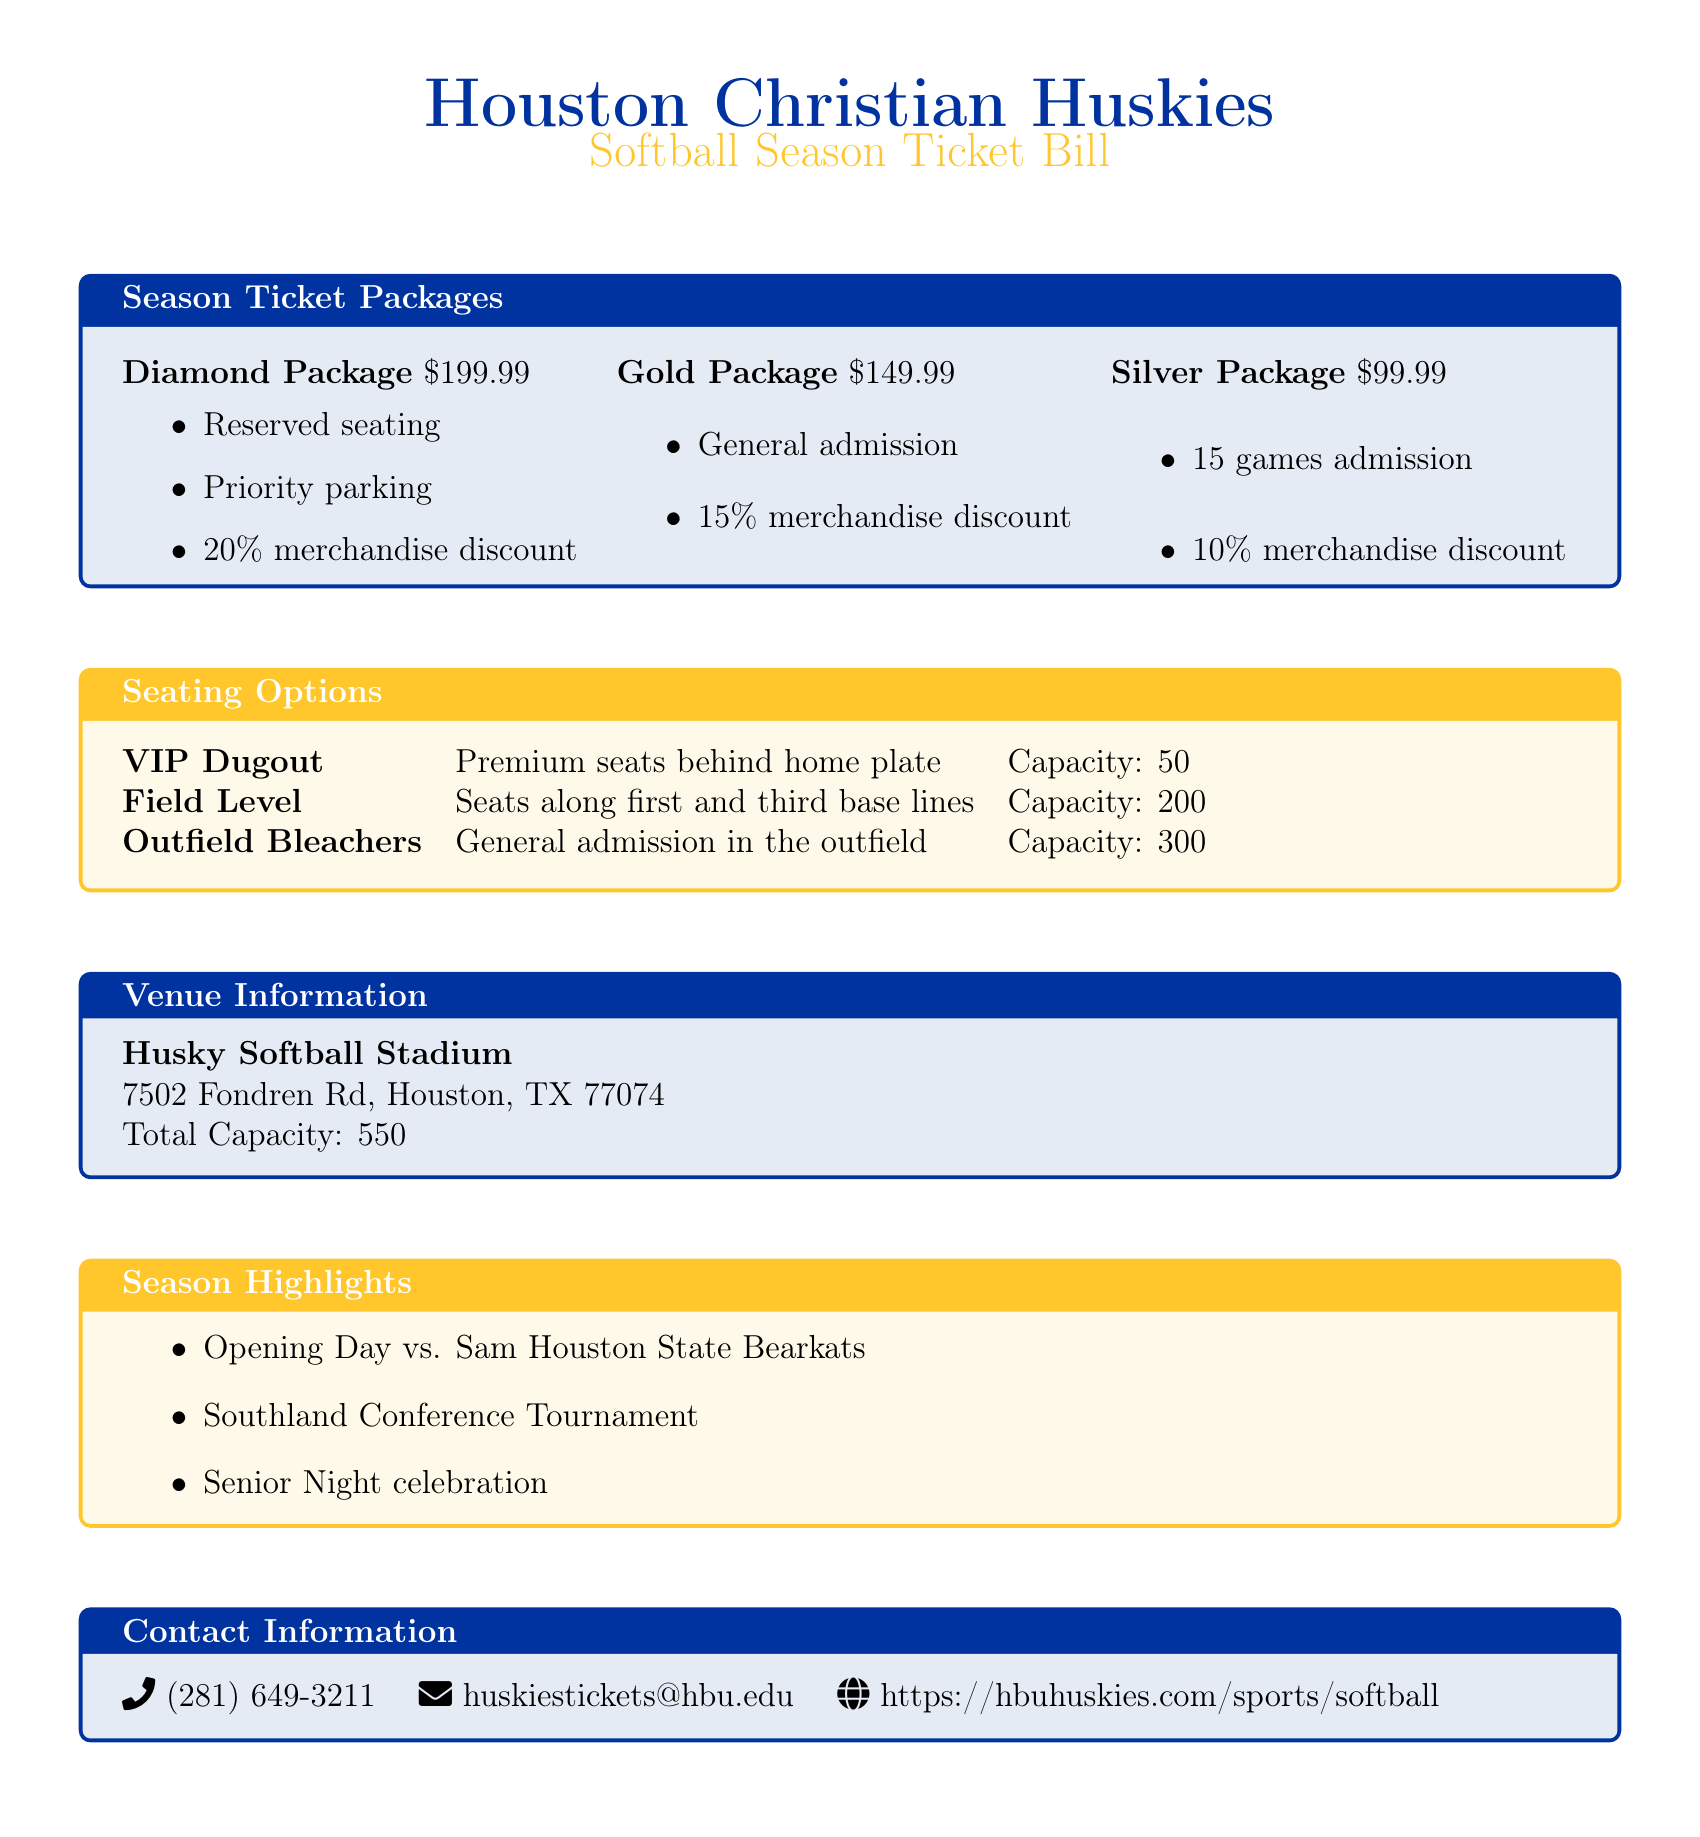What is the price of the Diamond Package? The price of the Diamond Package is listed in the document under season ticket packages.
Answer: $199.99 What discount do Diamond Package holders receive on merchandise? The merchandise discount for Diamond Package holders is specified in the season ticket packages section.
Answer: 20% How many games can Silver Package holders attend? The number of games for Silver Package holders is detailed in the package descriptions.
Answer: 15 games What is the total capacity of Husky Softball Stadium? The total capacity of the stadium is mentioned in the Venue Information section of the document.
Answer: 550 Which package offers priority parking? The package that includes priority parking is identified in the season ticket packages section.
Answer: Diamond Package What is the seating capacity of the VIP Dugout? The seating capacity of the VIP Dugout is found in the seating options table.
Answer: 50 What event is highlighted as opening day? The opening day event is specified in the season highlights section of the document.
Answer: vs. Sam Houston State Bearkats What is the contact email for Huskies tickets? The contact email for Huskies tickets is provided in the contact information section.
Answer: huskiestickets@hbu.edu 